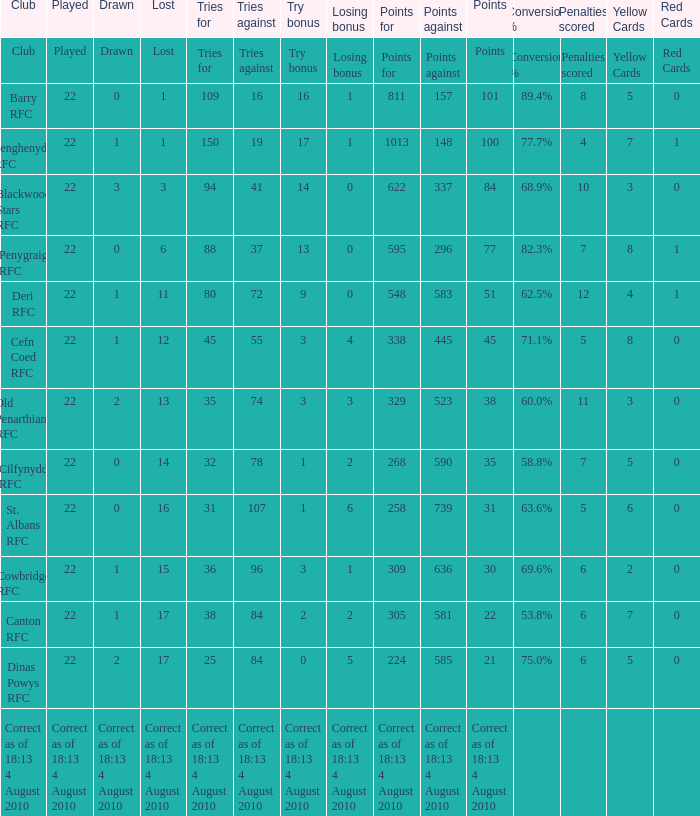What is the lost when the club was Barry RFC? 1.0. 